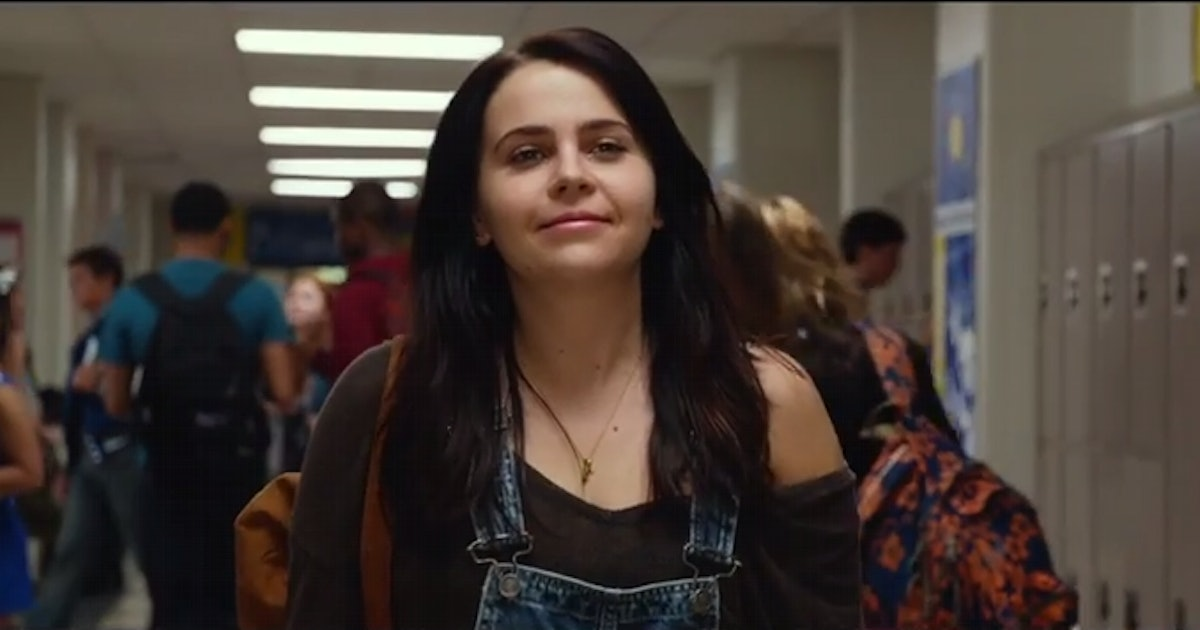How might this scene change if it were set in the 1980s? If this scene were set in the 1980s, the visual aesthetic would shift dramatically. The hallway would be adorned with posters of rock bands and motivational school slogans, and the students might be sporting vibrant, colorful clothing reflective of the era’s fashion—think bold patterns, denim jackets, and lots of neon. The central character might have big hair, possibly styled with a headband and wearing leg warmers over her jeans. Instead of a modern backpack, she might be carrying a retro, colorful bag slung over her shoulder. The overall vibe would be nostalgic, with a soundtrack of synthesizer-heavy tunes playing in the background, creating a lively and distinctly 80s atmosphere. 